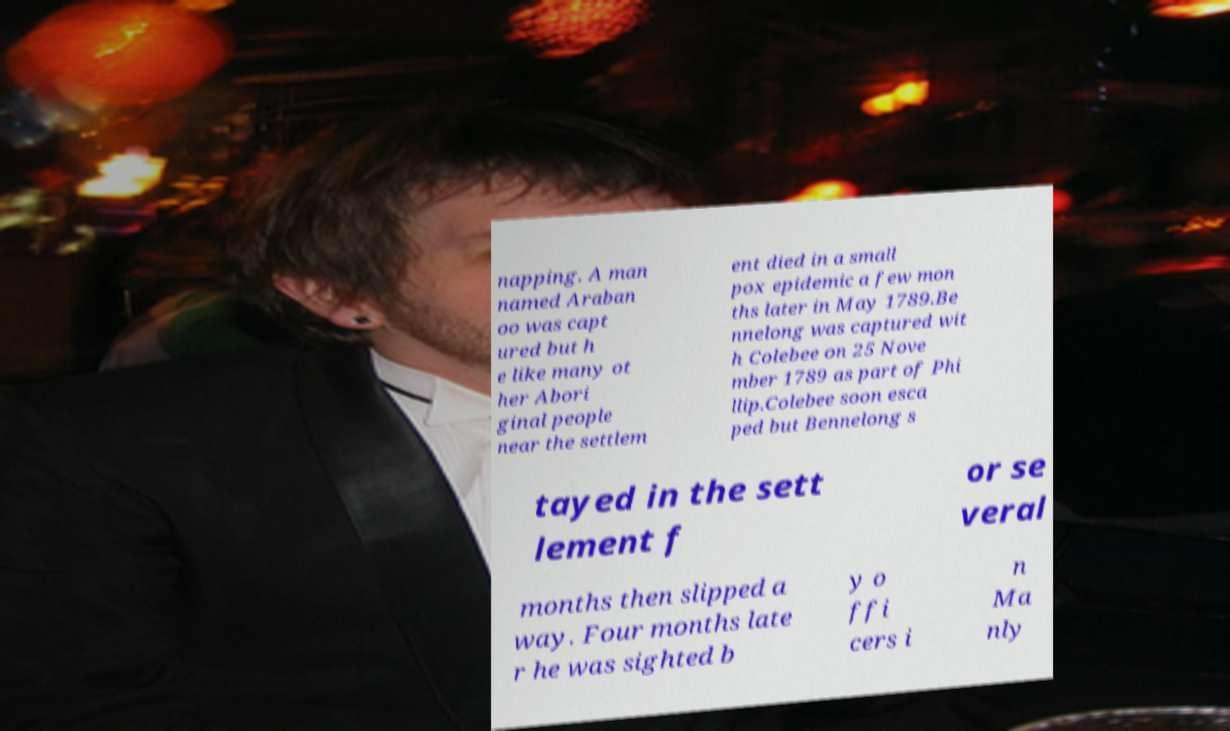Can you accurately transcribe the text from the provided image for me? napping. A man named Araban oo was capt ured but h e like many ot her Abori ginal people near the settlem ent died in a small pox epidemic a few mon ths later in May 1789.Be nnelong was captured wit h Colebee on 25 Nove mber 1789 as part of Phi llip.Colebee soon esca ped but Bennelong s tayed in the sett lement f or se veral months then slipped a way. Four months late r he was sighted b y o ffi cers i n Ma nly 